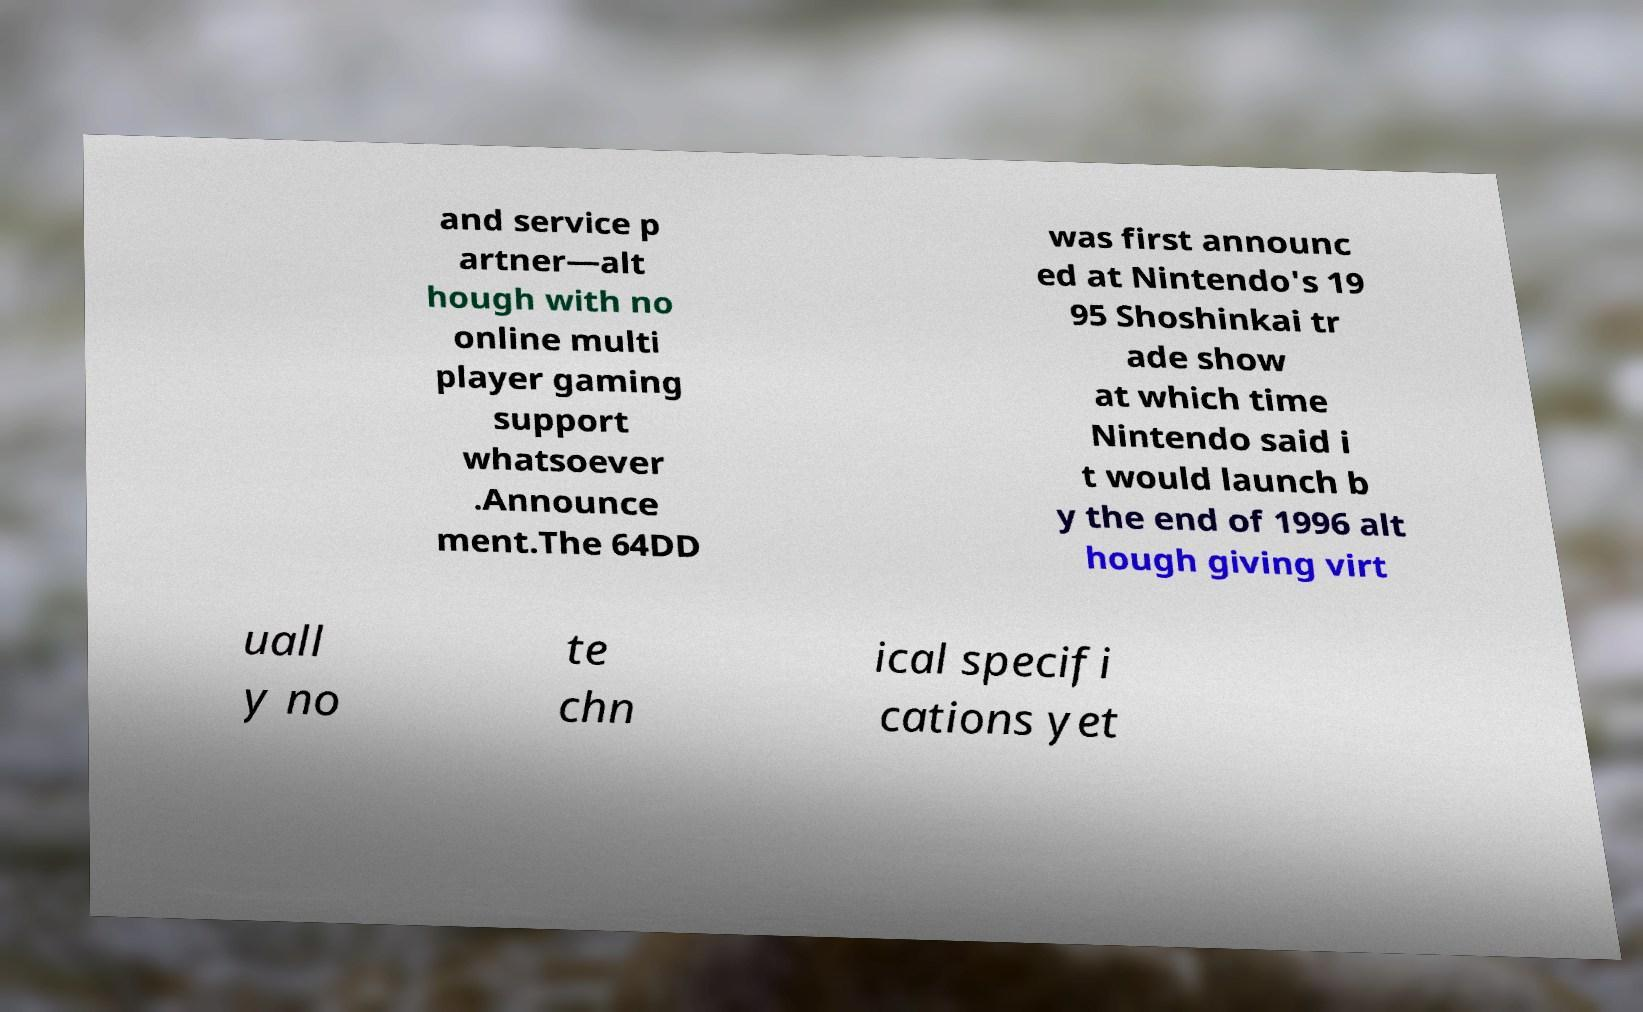What messages or text are displayed in this image? I need them in a readable, typed format. and service p artner—alt hough with no online multi player gaming support whatsoever .Announce ment.The 64DD was first announc ed at Nintendo's 19 95 Shoshinkai tr ade show at which time Nintendo said i t would launch b y the end of 1996 alt hough giving virt uall y no te chn ical specifi cations yet 